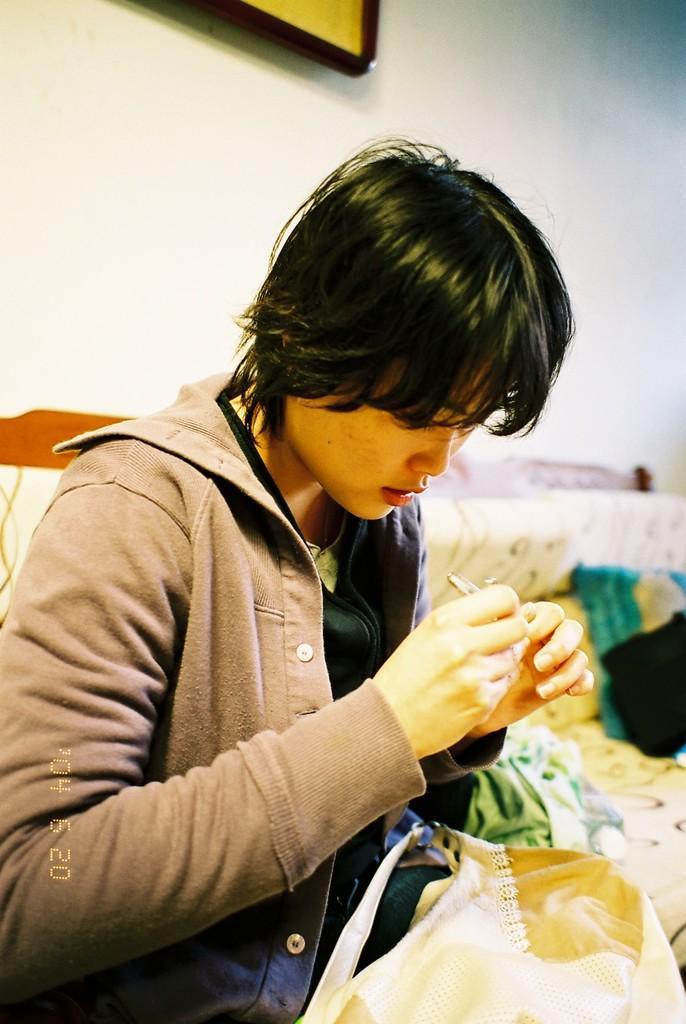Describe this image in one or two sentences. This image consists of a person. He is cutting his nails. He is wearing a jacket. He is sitting on a sofa. There is a photo frame at the top. 